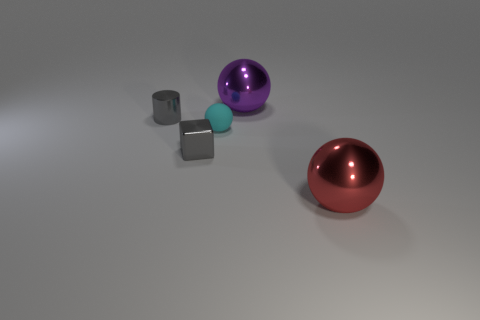There is a shiny thing that is to the right of the big shiny object behind the tiny block; what is its size?
Keep it short and to the point. Large. How many large things are either blocks or shiny balls?
Your answer should be compact. 2. How many other things are the same color as the tiny shiny cube?
Keep it short and to the point. 1. Does the metallic ball that is on the left side of the big red metal object have the same size as the ball in front of the small cyan sphere?
Provide a short and direct response. Yes. Do the small cylinder and the sphere that is left of the big purple sphere have the same material?
Give a very brief answer. No. Are there more tiny gray metal blocks to the right of the tiny cylinder than gray cylinders right of the small cyan object?
Your response must be concise. Yes. What is the color of the thing that is right of the shiny sphere left of the big red object?
Provide a short and direct response. Red. How many spheres are either matte things or tiny yellow matte objects?
Ensure brevity in your answer.  1. What number of metallic things are behind the cyan thing and to the right of the small metal cylinder?
Provide a short and direct response. 1. There is a shiny object that is on the left side of the tiny gray metal block; what color is it?
Offer a very short reply. Gray. 